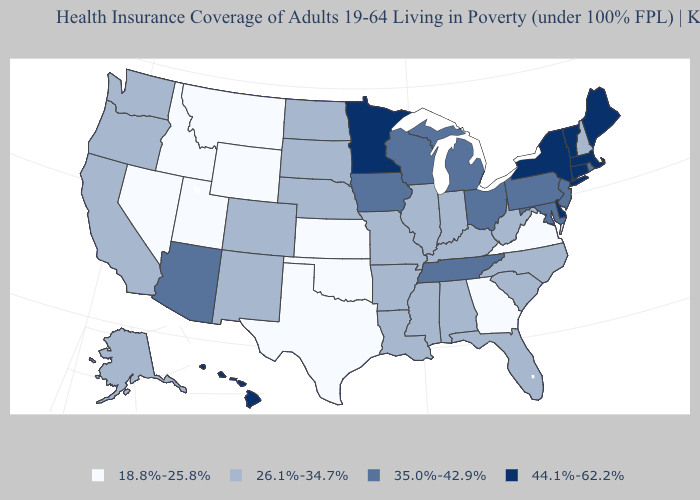Which states hav the highest value in the Northeast?
Give a very brief answer. Connecticut, Maine, Massachusetts, New York, Vermont. What is the highest value in the USA?
Write a very short answer. 44.1%-62.2%. What is the lowest value in the Northeast?
Write a very short answer. 26.1%-34.7%. What is the value of Tennessee?
Give a very brief answer. 35.0%-42.9%. Is the legend a continuous bar?
Answer briefly. No. What is the lowest value in the South?
Keep it brief. 18.8%-25.8%. Among the states that border Colorado , which have the highest value?
Give a very brief answer. Arizona. Does Missouri have the lowest value in the USA?
Write a very short answer. No. Does Maryland have the lowest value in the South?
Be succinct. No. Does Alaska have the highest value in the West?
Answer briefly. No. What is the value of Iowa?
Write a very short answer. 35.0%-42.9%. Does the map have missing data?
Short answer required. No. Name the states that have a value in the range 44.1%-62.2%?
Be succinct. Connecticut, Delaware, Hawaii, Maine, Massachusetts, Minnesota, New York, Vermont. Does Nevada have a lower value than Wyoming?
Keep it brief. No. Among the states that border Iowa , which have the highest value?
Quick response, please. Minnesota. 